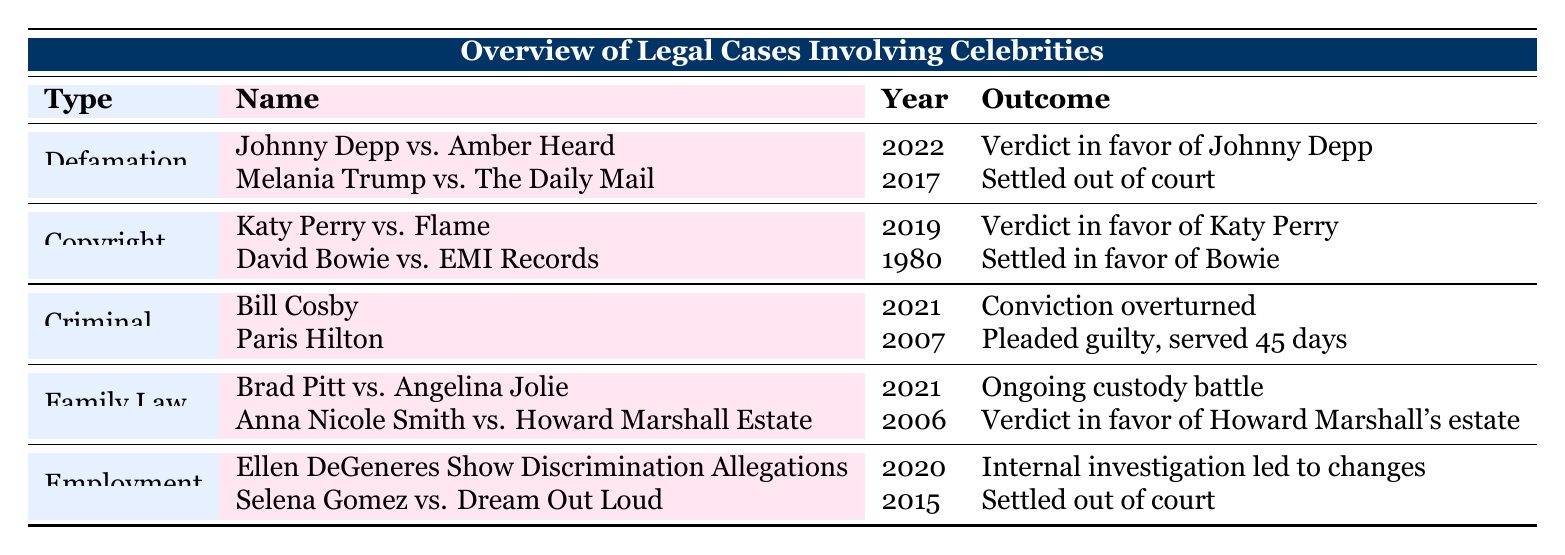What was the outcome of Johnny Depp vs. Amber Heard? The table indicates that the outcome in 2022 was "Verdict in favor of Johnny Depp."
Answer: Verdict in favor of Johnny Depp Which case involved Melania Trump and when did it occur? The table shows that Melania Trump was involved in a legal case against The Daily Mail in 2017.
Answer: Melania Trump vs. The Daily Mail in 2017 How many criminal cases are listed in the table? There are two criminal cases listed: Bill Cosby in 2021 and Paris Hilton in 2007, as noted in the Criminal section of the table.
Answer: 2 Did Anna Nicole Smith win her legal battle against Howard Marshall's estate? The table states that the outcome of Anna Nicole Smith vs. Howard Marshall Estate in 2006 was a verdict in favor of Howard Marshall's estate, meaning she did not win.
Answer: No In which year did Katy Perry win her copyright case? The table indicates that the verdict was in favor of Katy Perry in 2019, according to the Copyright section.
Answer: 2019 Which celebrity's legal case was settled out of court in 2015? The table notes that Selena Gomez vs. Dream Out Loud was settled out of court in 2015.
Answer: Selena Gomez How many cases resulted in a verdict favoring the celebrity? The table specifies that out of the cases listed, those resulting in a celebrity-favoring verdict are Johnny Depp vs. Amber Heard and Katy Perry vs. Flame, totaling two cases.
Answer: 2 Was there an employment-related legal issue in 2020? The table shows that the Ellen DeGeneres Show faced discrimination allegations which led to an internal investigation in 2020. Therefore, the statement is true.
Answer: Yes Which type of legal case had ongoing proceedings in 2021? According to the table, the Family Law section specifies that the ongoing custody battle case is Brad Pitt vs. Angelina Jolie in 2021.
Answer: Family Law 